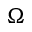Convert formula to latex. <formula><loc_0><loc_0><loc_500><loc_500>\Omega</formula> 